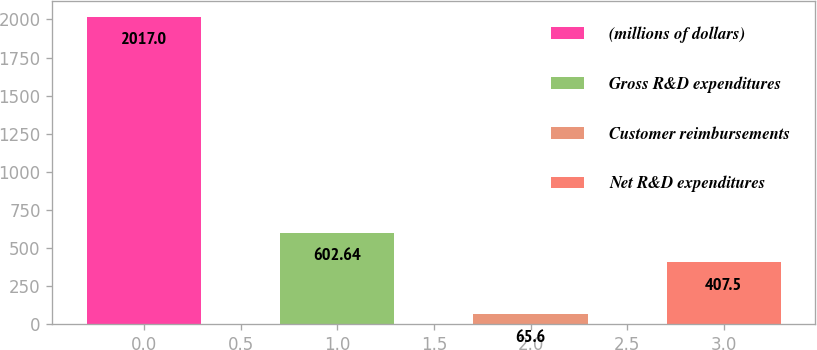Convert chart. <chart><loc_0><loc_0><loc_500><loc_500><bar_chart><fcel>(millions of dollars)<fcel>Gross R&D expenditures<fcel>Customer reimbursements<fcel>Net R&D expenditures<nl><fcel>2017<fcel>602.64<fcel>65.6<fcel>407.5<nl></chart> 